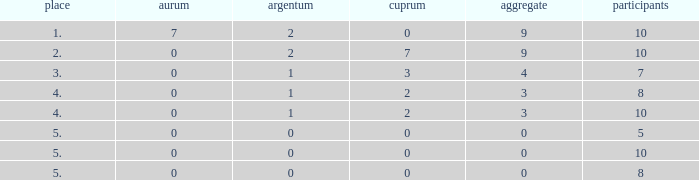Can you parse all the data within this table? {'header': ['place', 'aurum', 'argentum', 'cuprum', 'aggregate', 'participants'], 'rows': [['1.', '7', '2', '0', '9', '10'], ['2.', '0', '2', '7', '9', '10'], ['3.', '0', '1', '3', '4', '7'], ['4.', '0', '1', '2', '3', '8'], ['4.', '0', '1', '2', '3', '10'], ['5.', '0', '0', '0', '0', '5'], ['5.', '0', '0', '0', '0', '10'], ['5.', '0', '0', '0', '0', '8']]} What is listed as the highest Rank that has a Gold that's larger than 0, and Participants that's smaller than 10? None. 